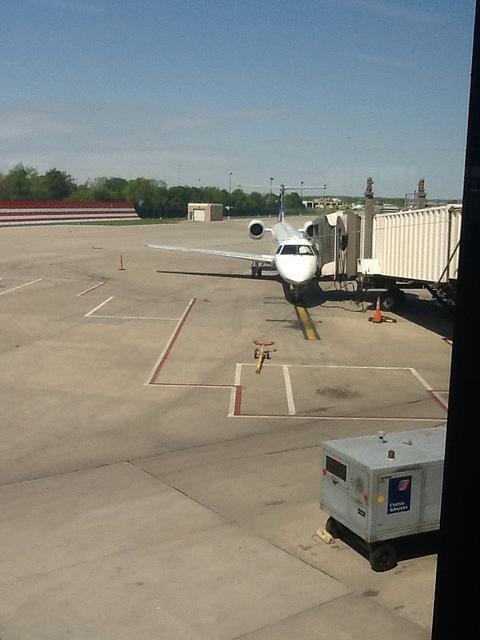How many vehicles are shown?
Give a very brief answer. 1. How many bows are on the cake but not the shoes?
Give a very brief answer. 0. 